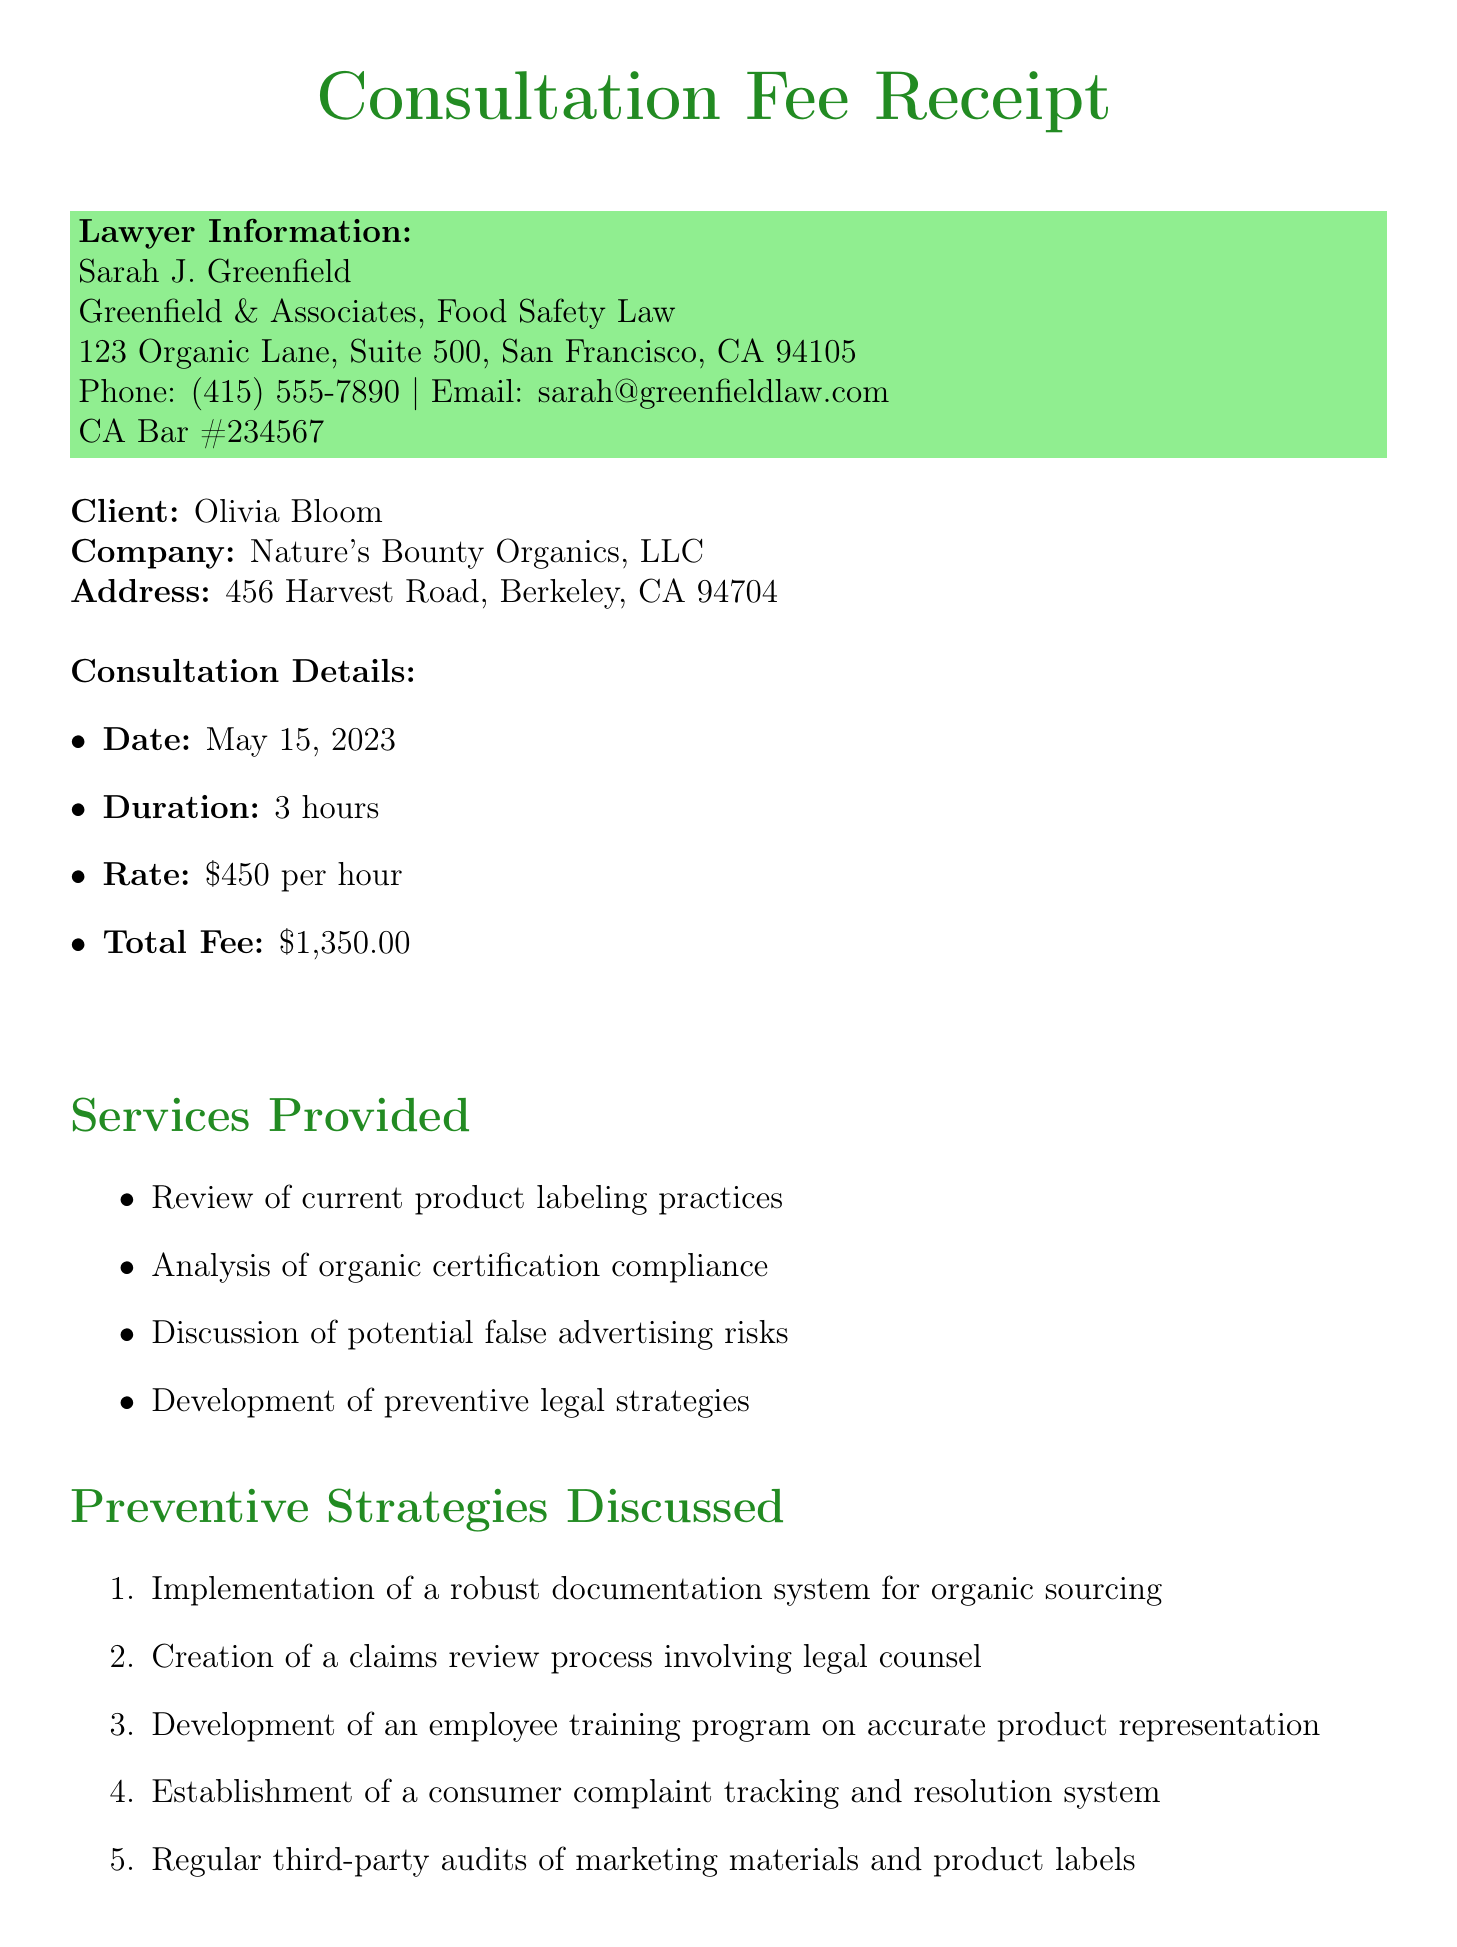What is the name of the lawyer? The document provides the name of the lawyer as listed in the lawyer information section.
Answer: Sarah J. Greenfield What is the total fee for the consultation? The total fee is specifically mentioned in the consultation details section of the document.
Answer: $1,350.00 On which date did the consultation take place? The date of the consultation is outlined in the consultation details.
Answer: May 15, 2023 How many hours was the consultation? The duration of the consultation is provided in the consultation details section.
Answer: 3 hours What type of payment method was used? The payment method is detailed in the payment information section of the document.
Answer: Credit Card (Visa ending in 4321) What was one preventive strategy discussed? The document lists several preventive strategies discussed during the consultation, requiring the reader to recall one of them.
Answer: Implementation of a robust documentation system for organic sourcing What are the recommended resources? This question requires referencing the recommended resources section for an authoritative source.
Answer: USDA Organic Regulations (7 CFR Part 205) What follow-up action is recommended regarding compliance reviews? This question asks for a specific follow-up action mentioned in the follow-up actions section of the document.
Answer: Schedule quarterly legal compliance reviews Why did the client express concern? The additional notes section includes details about what the client was particularly concerned with.
Answer: 'natural' and 'pesticide-free' claims 